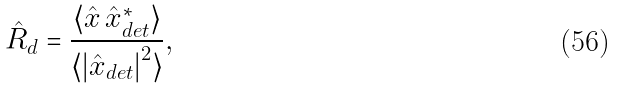Convert formula to latex. <formula><loc_0><loc_0><loc_500><loc_500>\hat { R } _ { d } = \frac { \langle \hat { x } \, \hat { x } _ { d e t } ^ { * } \rangle } { \langle { | \hat { x } _ { d e t } | } ^ { 2 } \rangle } ,</formula> 